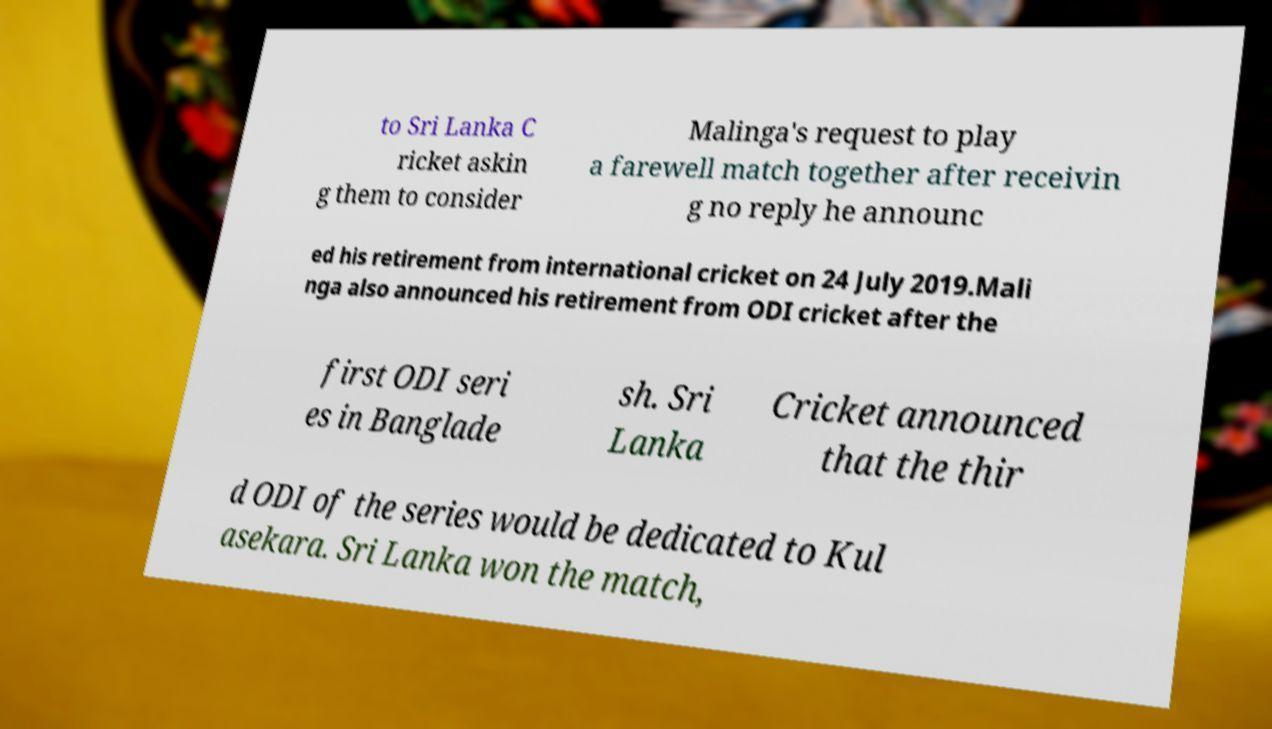Could you assist in decoding the text presented in this image and type it out clearly? to Sri Lanka C ricket askin g them to consider Malinga's request to play a farewell match together after receivin g no reply he announc ed his retirement from international cricket on 24 July 2019.Mali nga also announced his retirement from ODI cricket after the first ODI seri es in Banglade sh. Sri Lanka Cricket announced that the thir d ODI of the series would be dedicated to Kul asekara. Sri Lanka won the match, 